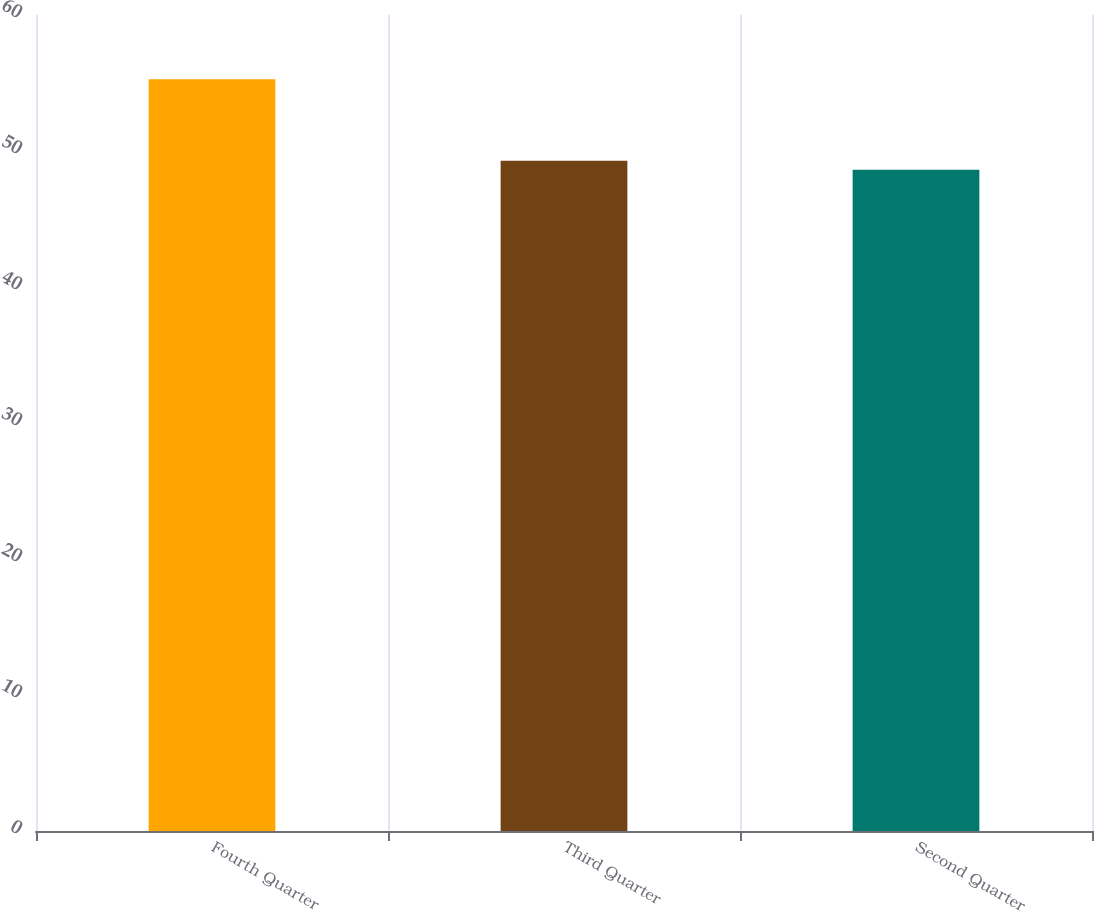<chart> <loc_0><loc_0><loc_500><loc_500><bar_chart><fcel>Fourth Quarter<fcel>Third Quarter<fcel>Second Quarter<nl><fcel>55.27<fcel>49.29<fcel>48.63<nl></chart> 